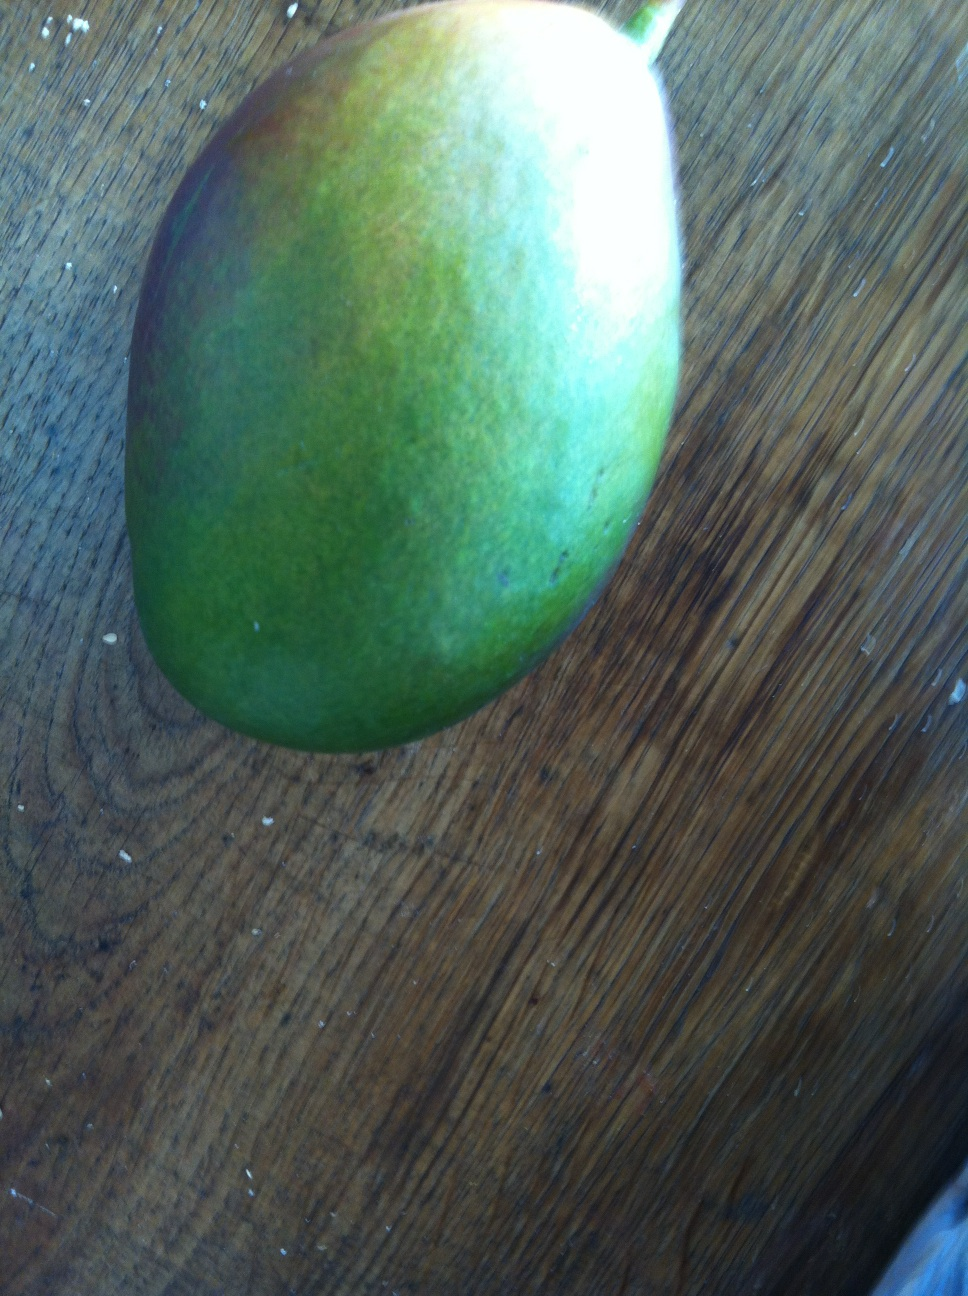How can one determine if this mango is sweet and ready to eat? To determine if a mango is sweet and ready to eat, look for a slight softness when you press gently against its skin. The aroma should be fragrant and fruity at the stem end. The color might not always be an accurate indicator due to the variety of mango species, but typically, a ripe mango will have a yellowish to reddish hue interspersed with its green background. 